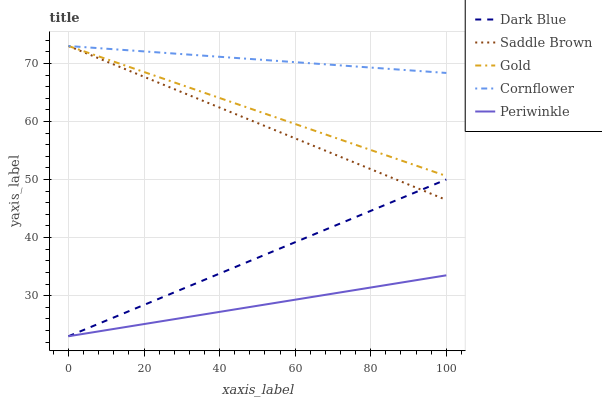Does Periwinkle have the minimum area under the curve?
Answer yes or no. Yes. Does Cornflower have the maximum area under the curve?
Answer yes or no. Yes. Does Saddle Brown have the minimum area under the curve?
Answer yes or no. No. Does Saddle Brown have the maximum area under the curve?
Answer yes or no. No. Is Periwinkle the smoothest?
Answer yes or no. Yes. Is Cornflower the roughest?
Answer yes or no. Yes. Is Saddle Brown the smoothest?
Answer yes or no. No. Is Saddle Brown the roughest?
Answer yes or no. No. Does Dark Blue have the lowest value?
Answer yes or no. Yes. Does Saddle Brown have the lowest value?
Answer yes or no. No. Does Cornflower have the highest value?
Answer yes or no. Yes. Does Periwinkle have the highest value?
Answer yes or no. No. Is Periwinkle less than Cornflower?
Answer yes or no. Yes. Is Gold greater than Periwinkle?
Answer yes or no. Yes. Does Gold intersect Cornflower?
Answer yes or no. Yes. Is Gold less than Cornflower?
Answer yes or no. No. Is Gold greater than Cornflower?
Answer yes or no. No. Does Periwinkle intersect Cornflower?
Answer yes or no. No. 